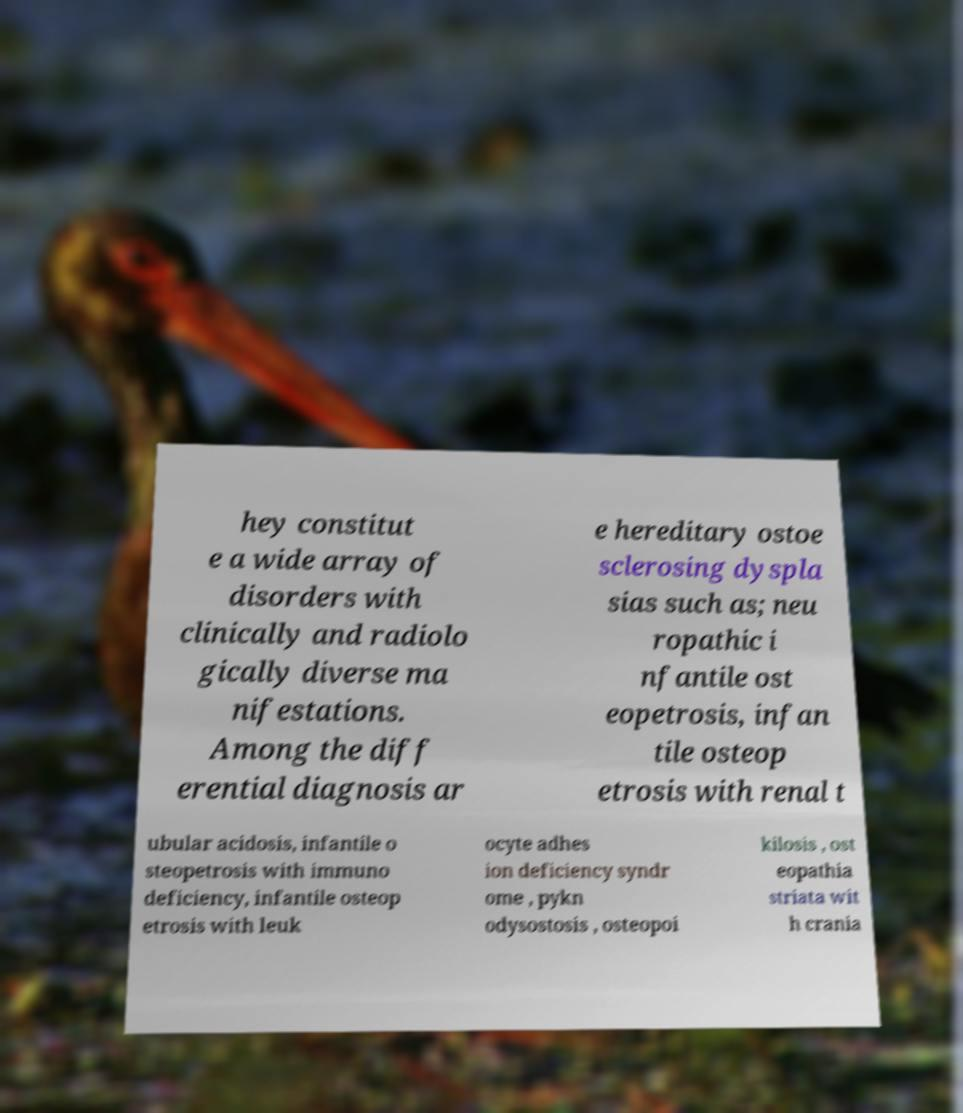Could you assist in decoding the text presented in this image and type it out clearly? hey constitut e a wide array of disorders with clinically and radiolo gically diverse ma nifestations. Among the diff erential diagnosis ar e hereditary ostoe sclerosing dyspla sias such as; neu ropathic i nfantile ost eopetrosis, infan tile osteop etrosis with renal t ubular acidosis, infantile o steopetrosis with immuno deficiency, infantile osteop etrosis with leuk ocyte adhes ion deficiency syndr ome , pykn odysostosis , osteopoi kilosis , ost eopathia striata wit h crania 